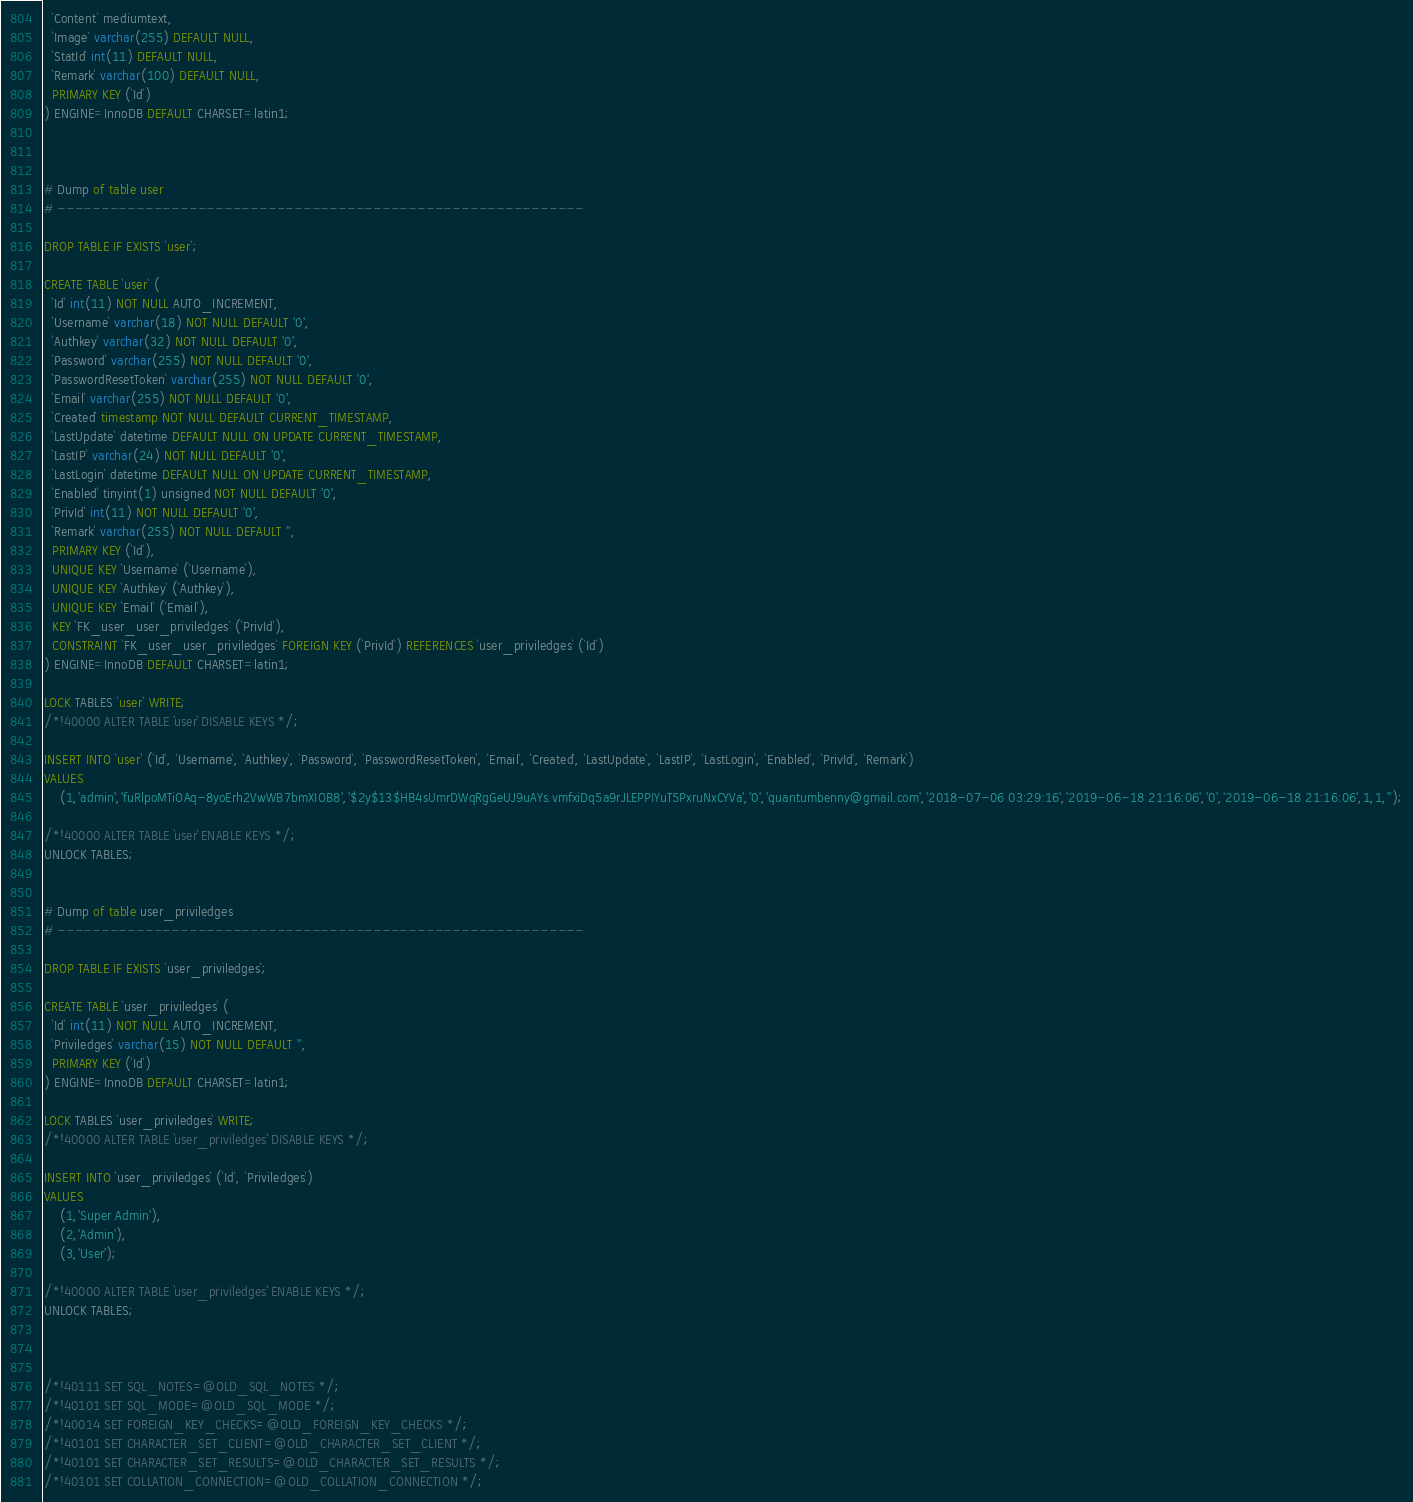Convert code to text. <code><loc_0><loc_0><loc_500><loc_500><_SQL_>  `Content` mediumtext,
  `Image` varchar(255) DEFAULT NULL,
  `StatId` int(11) DEFAULT NULL,
  `Remark` varchar(100) DEFAULT NULL,
  PRIMARY KEY (`Id`)
) ENGINE=InnoDB DEFAULT CHARSET=latin1;



# Dump of table user
# ------------------------------------------------------------

DROP TABLE IF EXISTS `user`;

CREATE TABLE `user` (
  `Id` int(11) NOT NULL AUTO_INCREMENT,
  `Username` varchar(18) NOT NULL DEFAULT '0',
  `Authkey` varchar(32) NOT NULL DEFAULT '0',
  `Password` varchar(255) NOT NULL DEFAULT '0',
  `PasswordResetToken` varchar(255) NOT NULL DEFAULT '0',
  `Email` varchar(255) NOT NULL DEFAULT '0',
  `Created` timestamp NOT NULL DEFAULT CURRENT_TIMESTAMP,
  `LastUpdate` datetime DEFAULT NULL ON UPDATE CURRENT_TIMESTAMP,
  `LastIP` varchar(24) NOT NULL DEFAULT '0',
  `LastLogin` datetime DEFAULT NULL ON UPDATE CURRENT_TIMESTAMP,
  `Enabled` tinyint(1) unsigned NOT NULL DEFAULT '0',
  `PrivId` int(11) NOT NULL DEFAULT '0',
  `Remark` varchar(255) NOT NULL DEFAULT '',
  PRIMARY KEY (`Id`),
  UNIQUE KEY `Username` (`Username`),
  UNIQUE KEY `Authkey` (`Authkey`),
  UNIQUE KEY `Email` (`Email`),
  KEY `FK_user_user_priviledges` (`PrivId`),
  CONSTRAINT `FK_user_user_priviledges` FOREIGN KEY (`PrivId`) REFERENCES `user_priviledges` (`Id`)
) ENGINE=InnoDB DEFAULT CHARSET=latin1;

LOCK TABLES `user` WRITE;
/*!40000 ALTER TABLE `user` DISABLE KEYS */;

INSERT INTO `user` (`Id`, `Username`, `Authkey`, `Password`, `PasswordResetToken`, `Email`, `Created`, `LastUpdate`, `LastIP`, `LastLogin`, `Enabled`, `PrivId`, `Remark`)
VALUES
	(1,'admin','fuRlpoMTiOAq-8yoErh2VwWB7bmXIOB8','$2y$13$HB4sUmrDWqRgGeUJ9uAYs.vmfxiDq5a9rJLEPPIYuT5PxruNxCYVa','0','quantumbenny@gmail.com','2018-07-06 03:29:16','2019-06-18 21:16:06','0','2019-06-18 21:16:06',1,1,'');

/*!40000 ALTER TABLE `user` ENABLE KEYS */;
UNLOCK TABLES;


# Dump of table user_priviledges
# ------------------------------------------------------------

DROP TABLE IF EXISTS `user_priviledges`;

CREATE TABLE `user_priviledges` (
  `Id` int(11) NOT NULL AUTO_INCREMENT,
  `Priviledges` varchar(15) NOT NULL DEFAULT '',
  PRIMARY KEY (`Id`)
) ENGINE=InnoDB DEFAULT CHARSET=latin1;

LOCK TABLES `user_priviledges` WRITE;
/*!40000 ALTER TABLE `user_priviledges` DISABLE KEYS */;

INSERT INTO `user_priviledges` (`Id`, `Priviledges`)
VALUES
	(1,'Super Admin'),
	(2,'Admin'),
	(3,'User');

/*!40000 ALTER TABLE `user_priviledges` ENABLE KEYS */;
UNLOCK TABLES;



/*!40111 SET SQL_NOTES=@OLD_SQL_NOTES */;
/*!40101 SET SQL_MODE=@OLD_SQL_MODE */;
/*!40014 SET FOREIGN_KEY_CHECKS=@OLD_FOREIGN_KEY_CHECKS */;
/*!40101 SET CHARACTER_SET_CLIENT=@OLD_CHARACTER_SET_CLIENT */;
/*!40101 SET CHARACTER_SET_RESULTS=@OLD_CHARACTER_SET_RESULTS */;
/*!40101 SET COLLATION_CONNECTION=@OLD_COLLATION_CONNECTION */;
</code> 